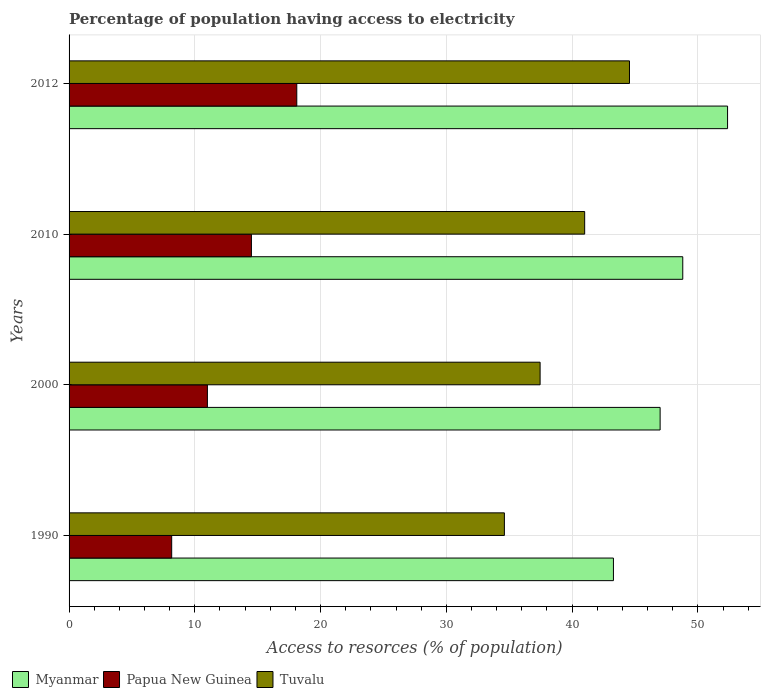How many different coloured bars are there?
Keep it short and to the point. 3. How many bars are there on the 1st tick from the top?
Your response must be concise. 3. In how many cases, is the number of bars for a given year not equal to the number of legend labels?
Give a very brief answer. 0. What is the percentage of population having access to electricity in Tuvalu in 2012?
Give a very brief answer. 44.56. Across all years, what is the maximum percentage of population having access to electricity in Myanmar?
Your response must be concise. 52.36. Across all years, what is the minimum percentage of population having access to electricity in Myanmar?
Your answer should be very brief. 43.29. What is the total percentage of population having access to electricity in Papua New Guinea in the graph?
Your answer should be very brief. 51.77. What is the difference between the percentage of population having access to electricity in Myanmar in 2010 and that in 2012?
Offer a very short reply. -3.56. What is the difference between the percentage of population having access to electricity in Myanmar in 2010 and the percentage of population having access to electricity in Tuvalu in 2000?
Give a very brief answer. 11.34. What is the average percentage of population having access to electricity in Myanmar per year?
Your answer should be compact. 47.86. In the year 1990, what is the difference between the percentage of population having access to electricity in Myanmar and percentage of population having access to electricity in Papua New Guinea?
Your answer should be compact. 35.13. In how many years, is the percentage of population having access to electricity in Papua New Guinea greater than 6 %?
Give a very brief answer. 4. What is the ratio of the percentage of population having access to electricity in Papua New Guinea in 1990 to that in 2000?
Offer a very short reply. 0.74. What is the difference between the highest and the second highest percentage of population having access to electricity in Myanmar?
Ensure brevity in your answer.  3.56. What is the difference between the highest and the lowest percentage of population having access to electricity in Papua New Guinea?
Your answer should be compact. 9.95. In how many years, is the percentage of population having access to electricity in Tuvalu greater than the average percentage of population having access to electricity in Tuvalu taken over all years?
Your response must be concise. 2. Is the sum of the percentage of population having access to electricity in Papua New Guinea in 2000 and 2012 greater than the maximum percentage of population having access to electricity in Myanmar across all years?
Provide a short and direct response. No. What does the 1st bar from the top in 1990 represents?
Your response must be concise. Tuvalu. What does the 3rd bar from the bottom in 2000 represents?
Keep it short and to the point. Tuvalu. Is it the case that in every year, the sum of the percentage of population having access to electricity in Tuvalu and percentage of population having access to electricity in Myanmar is greater than the percentage of population having access to electricity in Papua New Guinea?
Provide a short and direct response. Yes. Are all the bars in the graph horizontal?
Provide a short and direct response. Yes. How many years are there in the graph?
Ensure brevity in your answer.  4. What is the difference between two consecutive major ticks on the X-axis?
Provide a short and direct response. 10. Are the values on the major ticks of X-axis written in scientific E-notation?
Your answer should be very brief. No. Does the graph contain any zero values?
Make the answer very short. No. Where does the legend appear in the graph?
Your answer should be compact. Bottom left. How many legend labels are there?
Give a very brief answer. 3. How are the legend labels stacked?
Your answer should be compact. Horizontal. What is the title of the graph?
Your answer should be compact. Percentage of population having access to electricity. Does "Tanzania" appear as one of the legend labels in the graph?
Your response must be concise. No. What is the label or title of the X-axis?
Your answer should be compact. Access to resorces (% of population). What is the label or title of the Y-axis?
Provide a short and direct response. Years. What is the Access to resorces (% of population) of Myanmar in 1990?
Your answer should be compact. 43.29. What is the Access to resorces (% of population) of Papua New Guinea in 1990?
Your response must be concise. 8.16. What is the Access to resorces (% of population) in Tuvalu in 1990?
Make the answer very short. 34.62. What is the Access to resorces (% of population) in Myanmar in 2000?
Make the answer very short. 47. What is the Access to resorces (% of population) of Papua New Guinea in 2000?
Keep it short and to the point. 11. What is the Access to resorces (% of population) of Tuvalu in 2000?
Provide a succinct answer. 37.46. What is the Access to resorces (% of population) of Myanmar in 2010?
Provide a succinct answer. 48.8. What is the Access to resorces (% of population) in Tuvalu in 2010?
Ensure brevity in your answer.  41. What is the Access to resorces (% of population) in Myanmar in 2012?
Ensure brevity in your answer.  52.36. What is the Access to resorces (% of population) in Papua New Guinea in 2012?
Offer a very short reply. 18.11. What is the Access to resorces (% of population) in Tuvalu in 2012?
Your answer should be very brief. 44.56. Across all years, what is the maximum Access to resorces (% of population) in Myanmar?
Your response must be concise. 52.36. Across all years, what is the maximum Access to resorces (% of population) in Papua New Guinea?
Your answer should be compact. 18.11. Across all years, what is the maximum Access to resorces (% of population) in Tuvalu?
Your answer should be very brief. 44.56. Across all years, what is the minimum Access to resorces (% of population) of Myanmar?
Offer a very short reply. 43.29. Across all years, what is the minimum Access to resorces (% of population) in Papua New Guinea?
Make the answer very short. 8.16. Across all years, what is the minimum Access to resorces (% of population) in Tuvalu?
Ensure brevity in your answer.  34.62. What is the total Access to resorces (% of population) of Myanmar in the graph?
Ensure brevity in your answer.  191.45. What is the total Access to resorces (% of population) of Papua New Guinea in the graph?
Make the answer very short. 51.77. What is the total Access to resorces (% of population) in Tuvalu in the graph?
Provide a succinct answer. 157.63. What is the difference between the Access to resorces (% of population) of Myanmar in 1990 and that in 2000?
Your answer should be compact. -3.71. What is the difference between the Access to resorces (% of population) in Papua New Guinea in 1990 and that in 2000?
Your response must be concise. -2.84. What is the difference between the Access to resorces (% of population) of Tuvalu in 1990 and that in 2000?
Offer a terse response. -2.84. What is the difference between the Access to resorces (% of population) in Myanmar in 1990 and that in 2010?
Make the answer very short. -5.51. What is the difference between the Access to resorces (% of population) of Papua New Guinea in 1990 and that in 2010?
Your answer should be very brief. -6.34. What is the difference between the Access to resorces (% of population) in Tuvalu in 1990 and that in 2010?
Provide a succinct answer. -6.38. What is the difference between the Access to resorces (% of population) of Myanmar in 1990 and that in 2012?
Your response must be concise. -9.07. What is the difference between the Access to resorces (% of population) in Papua New Guinea in 1990 and that in 2012?
Your response must be concise. -9.95. What is the difference between the Access to resorces (% of population) of Tuvalu in 1990 and that in 2012?
Your response must be concise. -9.95. What is the difference between the Access to resorces (% of population) of Myanmar in 2000 and that in 2010?
Your answer should be very brief. -1.8. What is the difference between the Access to resorces (% of population) in Papua New Guinea in 2000 and that in 2010?
Your response must be concise. -3.5. What is the difference between the Access to resorces (% of population) in Tuvalu in 2000 and that in 2010?
Keep it short and to the point. -3.54. What is the difference between the Access to resorces (% of population) in Myanmar in 2000 and that in 2012?
Offer a terse response. -5.36. What is the difference between the Access to resorces (% of population) in Papua New Guinea in 2000 and that in 2012?
Make the answer very short. -7.11. What is the difference between the Access to resorces (% of population) of Tuvalu in 2000 and that in 2012?
Give a very brief answer. -7.11. What is the difference between the Access to resorces (% of population) of Myanmar in 2010 and that in 2012?
Your response must be concise. -3.56. What is the difference between the Access to resorces (% of population) of Papua New Guinea in 2010 and that in 2012?
Offer a terse response. -3.61. What is the difference between the Access to resorces (% of population) in Tuvalu in 2010 and that in 2012?
Keep it short and to the point. -3.56. What is the difference between the Access to resorces (% of population) in Myanmar in 1990 and the Access to resorces (% of population) in Papua New Guinea in 2000?
Provide a short and direct response. 32.29. What is the difference between the Access to resorces (% of population) of Myanmar in 1990 and the Access to resorces (% of population) of Tuvalu in 2000?
Your answer should be compact. 5.83. What is the difference between the Access to resorces (% of population) of Papua New Guinea in 1990 and the Access to resorces (% of population) of Tuvalu in 2000?
Make the answer very short. -29.3. What is the difference between the Access to resorces (% of population) of Myanmar in 1990 and the Access to resorces (% of population) of Papua New Guinea in 2010?
Give a very brief answer. 28.79. What is the difference between the Access to resorces (% of population) in Myanmar in 1990 and the Access to resorces (% of population) in Tuvalu in 2010?
Your answer should be compact. 2.29. What is the difference between the Access to resorces (% of population) in Papua New Guinea in 1990 and the Access to resorces (% of population) in Tuvalu in 2010?
Give a very brief answer. -32.84. What is the difference between the Access to resorces (% of population) in Myanmar in 1990 and the Access to resorces (% of population) in Papua New Guinea in 2012?
Provide a short and direct response. 25.18. What is the difference between the Access to resorces (% of population) in Myanmar in 1990 and the Access to resorces (% of population) in Tuvalu in 2012?
Keep it short and to the point. -1.27. What is the difference between the Access to resorces (% of population) of Papua New Guinea in 1990 and the Access to resorces (% of population) of Tuvalu in 2012?
Your response must be concise. -36.4. What is the difference between the Access to resorces (% of population) of Myanmar in 2000 and the Access to resorces (% of population) of Papua New Guinea in 2010?
Your response must be concise. 32.5. What is the difference between the Access to resorces (% of population) in Myanmar in 2000 and the Access to resorces (% of population) in Papua New Guinea in 2012?
Your response must be concise. 28.89. What is the difference between the Access to resorces (% of population) of Myanmar in 2000 and the Access to resorces (% of population) of Tuvalu in 2012?
Provide a short and direct response. 2.44. What is the difference between the Access to resorces (% of population) in Papua New Guinea in 2000 and the Access to resorces (% of population) in Tuvalu in 2012?
Your answer should be very brief. -33.56. What is the difference between the Access to resorces (% of population) in Myanmar in 2010 and the Access to resorces (% of population) in Papua New Guinea in 2012?
Keep it short and to the point. 30.69. What is the difference between the Access to resorces (% of population) of Myanmar in 2010 and the Access to resorces (% of population) of Tuvalu in 2012?
Make the answer very short. 4.24. What is the difference between the Access to resorces (% of population) in Papua New Guinea in 2010 and the Access to resorces (% of population) in Tuvalu in 2012?
Your answer should be very brief. -30.06. What is the average Access to resorces (% of population) in Myanmar per year?
Your answer should be compact. 47.86. What is the average Access to resorces (% of population) of Papua New Guinea per year?
Provide a succinct answer. 12.94. What is the average Access to resorces (% of population) in Tuvalu per year?
Ensure brevity in your answer.  39.41. In the year 1990, what is the difference between the Access to resorces (% of population) in Myanmar and Access to resorces (% of population) in Papua New Guinea?
Ensure brevity in your answer.  35.13. In the year 1990, what is the difference between the Access to resorces (% of population) in Myanmar and Access to resorces (% of population) in Tuvalu?
Your answer should be compact. 8.67. In the year 1990, what is the difference between the Access to resorces (% of population) of Papua New Guinea and Access to resorces (% of population) of Tuvalu?
Your answer should be very brief. -26.46. In the year 2000, what is the difference between the Access to resorces (% of population) of Myanmar and Access to resorces (% of population) of Tuvalu?
Give a very brief answer. 9.54. In the year 2000, what is the difference between the Access to resorces (% of population) in Papua New Guinea and Access to resorces (% of population) in Tuvalu?
Provide a short and direct response. -26.46. In the year 2010, what is the difference between the Access to resorces (% of population) of Myanmar and Access to resorces (% of population) of Papua New Guinea?
Your answer should be very brief. 34.3. In the year 2010, what is the difference between the Access to resorces (% of population) in Papua New Guinea and Access to resorces (% of population) in Tuvalu?
Provide a short and direct response. -26.5. In the year 2012, what is the difference between the Access to resorces (% of population) in Myanmar and Access to resorces (% of population) in Papua New Guinea?
Keep it short and to the point. 34.26. In the year 2012, what is the difference between the Access to resorces (% of population) of Papua New Guinea and Access to resorces (% of population) of Tuvalu?
Your answer should be very brief. -26.46. What is the ratio of the Access to resorces (% of population) of Myanmar in 1990 to that in 2000?
Your response must be concise. 0.92. What is the ratio of the Access to resorces (% of population) of Papua New Guinea in 1990 to that in 2000?
Keep it short and to the point. 0.74. What is the ratio of the Access to resorces (% of population) in Tuvalu in 1990 to that in 2000?
Keep it short and to the point. 0.92. What is the ratio of the Access to resorces (% of population) in Myanmar in 1990 to that in 2010?
Keep it short and to the point. 0.89. What is the ratio of the Access to resorces (% of population) in Papua New Guinea in 1990 to that in 2010?
Keep it short and to the point. 0.56. What is the ratio of the Access to resorces (% of population) in Tuvalu in 1990 to that in 2010?
Make the answer very short. 0.84. What is the ratio of the Access to resorces (% of population) in Myanmar in 1990 to that in 2012?
Make the answer very short. 0.83. What is the ratio of the Access to resorces (% of population) of Papua New Guinea in 1990 to that in 2012?
Ensure brevity in your answer.  0.45. What is the ratio of the Access to resorces (% of population) in Tuvalu in 1990 to that in 2012?
Your answer should be compact. 0.78. What is the ratio of the Access to resorces (% of population) of Myanmar in 2000 to that in 2010?
Keep it short and to the point. 0.96. What is the ratio of the Access to resorces (% of population) of Papua New Guinea in 2000 to that in 2010?
Your answer should be very brief. 0.76. What is the ratio of the Access to resorces (% of population) of Tuvalu in 2000 to that in 2010?
Your answer should be compact. 0.91. What is the ratio of the Access to resorces (% of population) in Myanmar in 2000 to that in 2012?
Ensure brevity in your answer.  0.9. What is the ratio of the Access to resorces (% of population) in Papua New Guinea in 2000 to that in 2012?
Offer a very short reply. 0.61. What is the ratio of the Access to resorces (% of population) of Tuvalu in 2000 to that in 2012?
Keep it short and to the point. 0.84. What is the ratio of the Access to resorces (% of population) of Myanmar in 2010 to that in 2012?
Keep it short and to the point. 0.93. What is the ratio of the Access to resorces (% of population) of Papua New Guinea in 2010 to that in 2012?
Your answer should be compact. 0.8. What is the ratio of the Access to resorces (% of population) in Tuvalu in 2010 to that in 2012?
Your response must be concise. 0.92. What is the difference between the highest and the second highest Access to resorces (% of population) in Myanmar?
Your response must be concise. 3.56. What is the difference between the highest and the second highest Access to resorces (% of population) in Papua New Guinea?
Keep it short and to the point. 3.61. What is the difference between the highest and the second highest Access to resorces (% of population) of Tuvalu?
Your answer should be compact. 3.56. What is the difference between the highest and the lowest Access to resorces (% of population) of Myanmar?
Provide a succinct answer. 9.07. What is the difference between the highest and the lowest Access to resorces (% of population) of Papua New Guinea?
Make the answer very short. 9.95. What is the difference between the highest and the lowest Access to resorces (% of population) of Tuvalu?
Give a very brief answer. 9.95. 